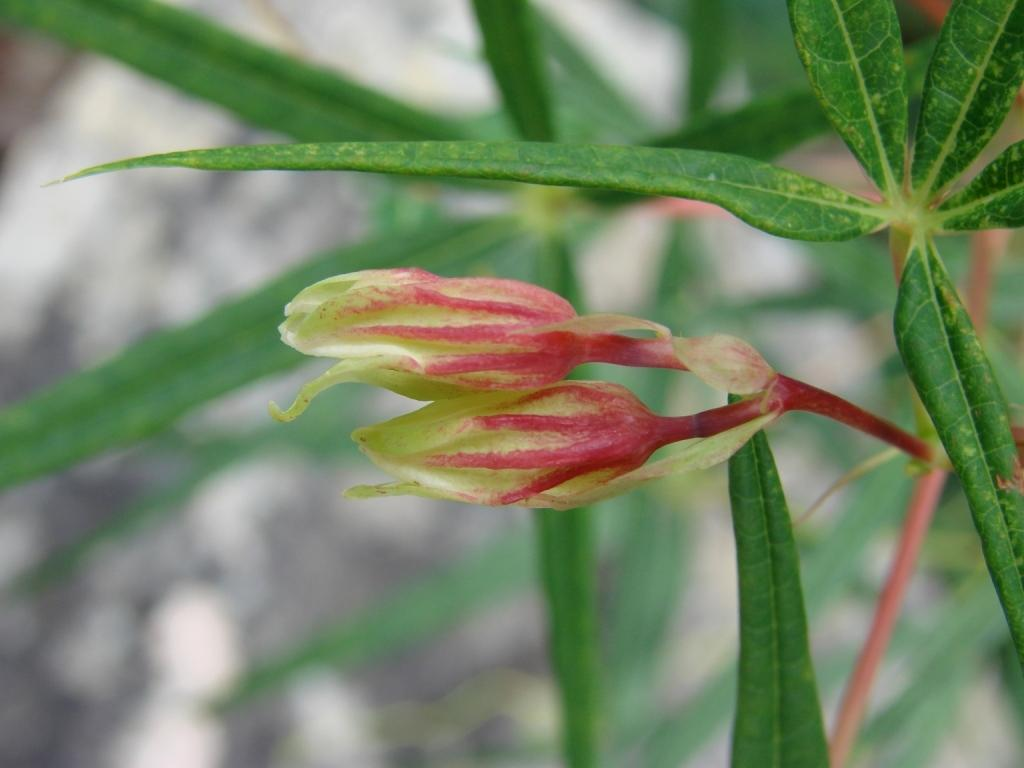What type of living organism is present in the image? There is a plant in the image. What specific features can be observed on the plant? The plant has flowers and green leaves. Can you describe the background of the image? The background of the image is blurred. What type of bubble can be seen floating near the plant in the image? There is no bubble present in the image; it only features a plant with flowers and green leaves against a blurred background. 